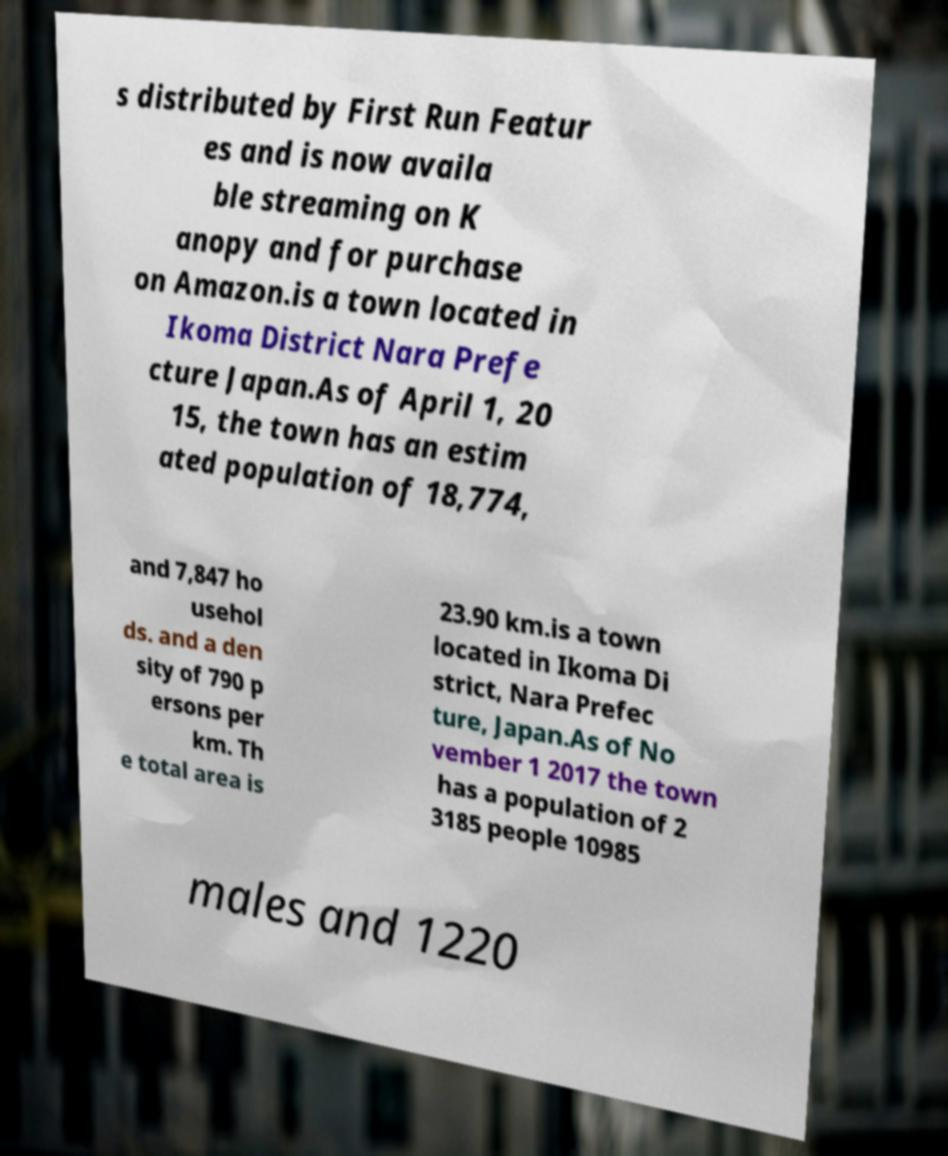Could you extract and type out the text from this image? s distributed by First Run Featur es and is now availa ble streaming on K anopy and for purchase on Amazon.is a town located in Ikoma District Nara Prefe cture Japan.As of April 1, 20 15, the town has an estim ated population of 18,774, and 7,847 ho usehol ds. and a den sity of 790 p ersons per km. Th e total area is 23.90 km.is a town located in Ikoma Di strict, Nara Prefec ture, Japan.As of No vember 1 2017 the town has a population of 2 3185 people 10985 males and 1220 